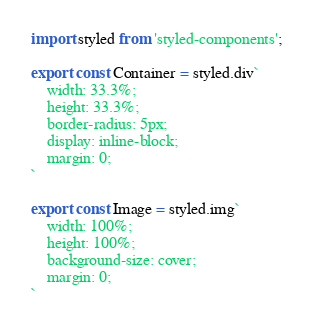<code> <loc_0><loc_0><loc_500><loc_500><_TypeScript_>import styled from 'styled-components';

export const Container = styled.div`
    width: 33.3%;
    height: 33.3%;
    border-radius: 5px;
    display: inline-block;
    margin: 0;
`

export const Image = styled.img`
    width: 100%;
    height: 100%;
    background-size: cover;
    margin: 0;
`</code> 